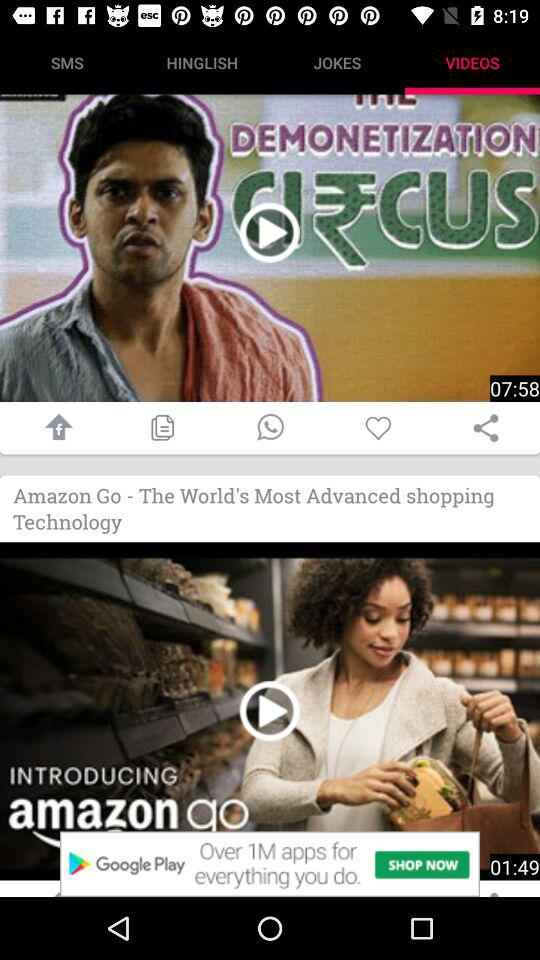How many videos are in "JOKES"?
When the provided information is insufficient, respond with <no answer>. <no answer> 